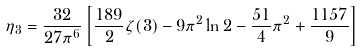<formula> <loc_0><loc_0><loc_500><loc_500>\eta _ { 3 } = \frac { 3 2 } { 2 7 \pi ^ { 6 } } \left [ \frac { 1 8 9 } { 2 } \zeta ( 3 ) - 9 \pi ^ { 2 } \ln 2 - \frac { 5 1 } { 4 } \pi ^ { 2 } + \frac { 1 1 5 7 } { 9 } \right ]</formula> 